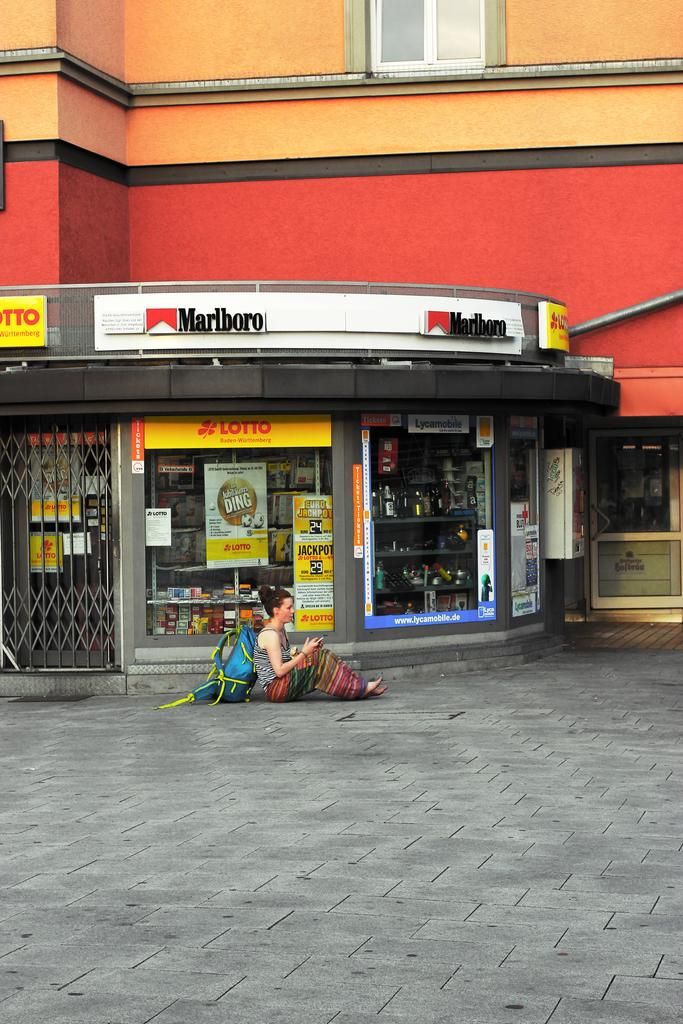<image>
Create a compact narrative representing the image presented. a backpackers sitting on the road in front of a LOTTO Malboro shop 